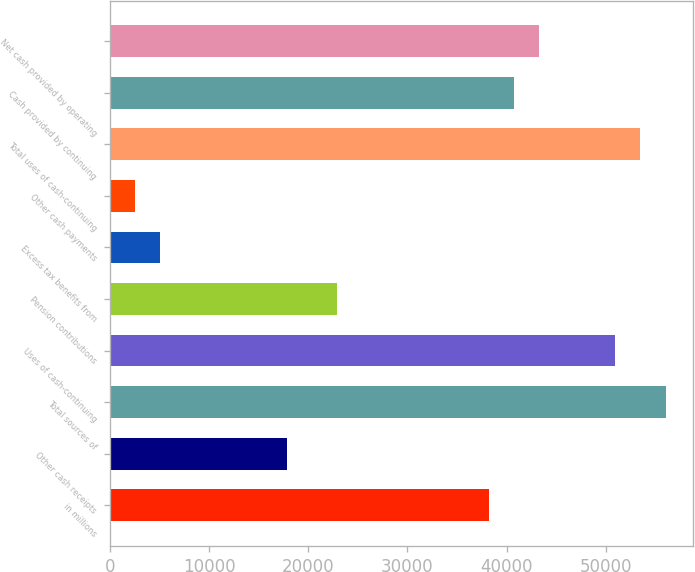Convert chart. <chart><loc_0><loc_0><loc_500><loc_500><bar_chart><fcel>in millions<fcel>Other cash receipts<fcel>Total sources of<fcel>Uses of cash-continuing<fcel>Pension contributions<fcel>Excess tax benefits from<fcel>Other cash payments<fcel>Total uses of cash-continuing<fcel>Cash provided by continuing<fcel>Net cash provided by operating<nl><fcel>38193<fcel>17825<fcel>56015<fcel>50923<fcel>22917<fcel>5095<fcel>2549<fcel>53469<fcel>40739<fcel>43285<nl></chart> 